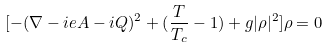Convert formula to latex. <formula><loc_0><loc_0><loc_500><loc_500>[ - ( { \nabla } - i e A - i Q ) ^ { 2 } + ( \frac { T } { T _ { c } } - 1 ) + g | { \rho } | ^ { 2 } ] { \rho } = 0</formula> 